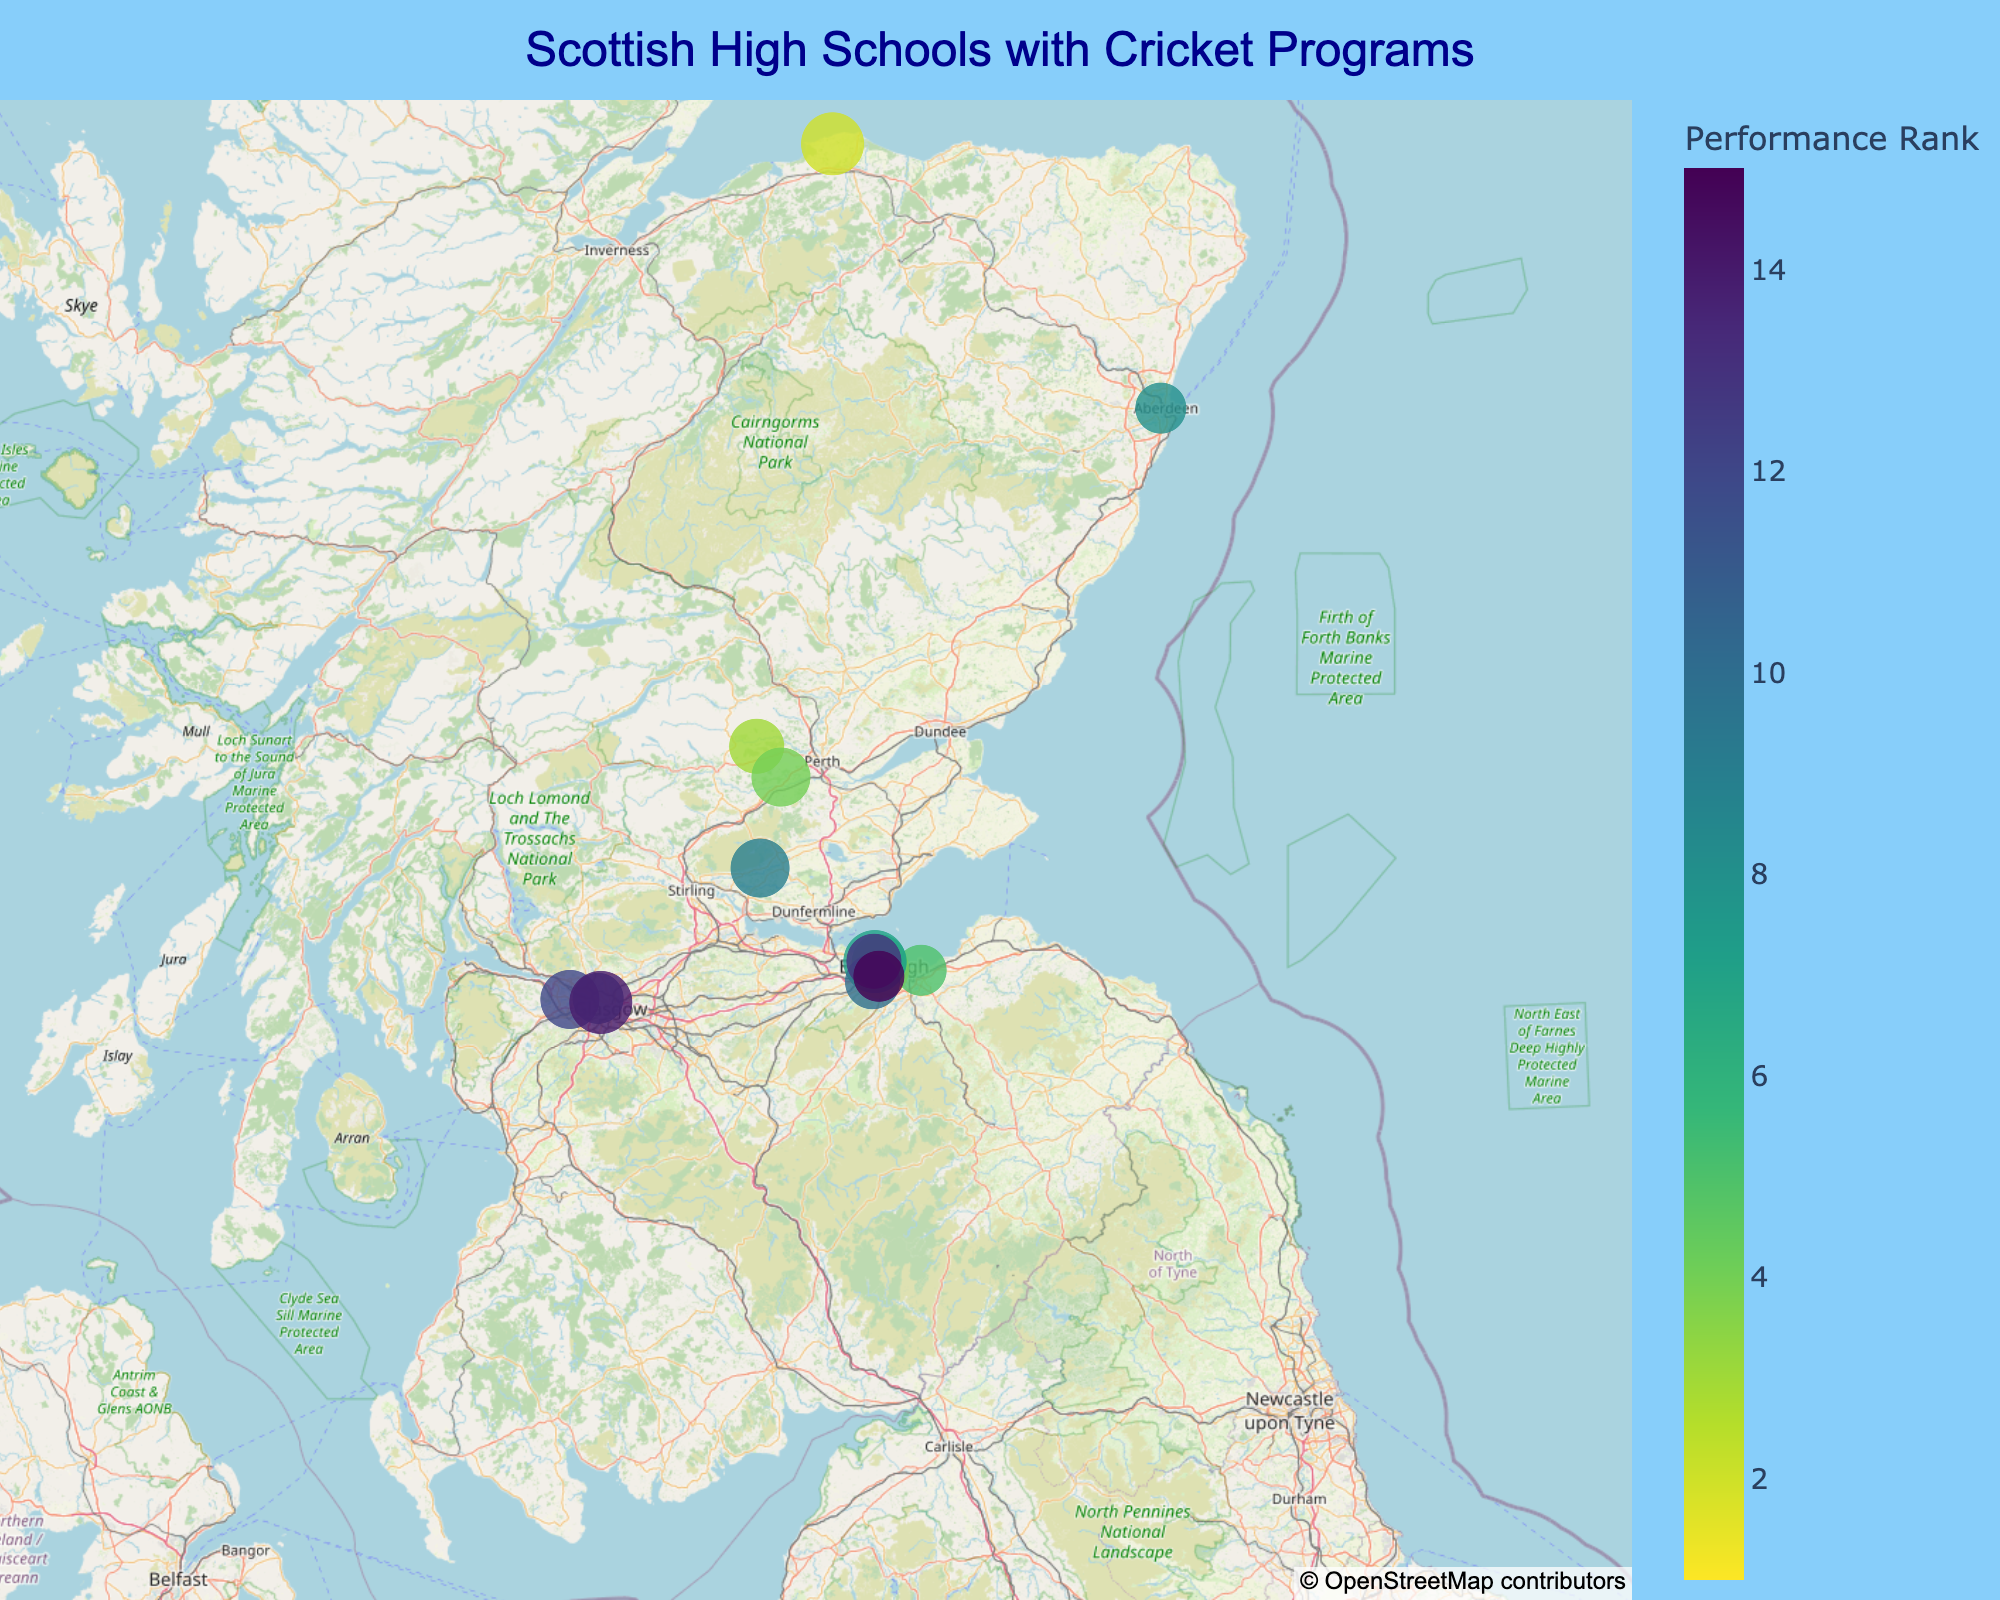What is the title of the geographic plot? The title is displayed at the top of the plot, centered and in a dark blue font. It reads "Scottish High Schools with Cricket Programs".
Answer: Scottish High Schools with Cricket Programs Which school has the highest performance rank and what is its team size? By examining the marker with the smallest numerical value for the Performance Rank, the highest rank is 1. The corresponding school is George Heriot's School, and its team size is shown as 15.
Answer: George Heriot's School, 15 What color is used to indicate the highest performance ranks, and what color represents the lowest? The color scheme used is the Viridis colorscale. The highest performance ranks are represented by colors at the darker end of the spectrum (dark purple), while the lowest ranks are represented by colors at the lighter end (yellow-green).
Answer: Dark purple, yellow-green How many schools have a team size of 14? By inspecting the markers, you see that different markers are sized according to team size. Counting the markers sized for team size 14, there are four schools with this size: Glenalmond College, Edinburgh Academy, Merchiston Castle School, and Stewart's Melville College.
Answer: 4 Which school is located furthest north and what is its performance rank? By examining the latitude values of the markers on the plot, the school located furthest north is Gordonstoun School, which has a latitude of 57.6985. Its performance rank is shown as 2.
Answer: Gordonstoun School, 2 What is the average performance rank of the schools located in Edinburgh? The schools located in Edinburgh are George Heriot's School (1), Loretto School (5), Edinburgh Academy (6), Fettes College (7), Stewart's Melville College (13), and George Watson's College (15). Calculate the average rank by summing these ranks and dividing by the number of schools: (1+5+6+7+13+15) / 6 = 47 / 6 = 7.83.
Answer: 7.83 Which school is closest to the center of the map? The center of the map is calculated as the mean latitude and longitude of all the schools. Mentally estimating or using precise calculation (Edinburgh region is centered, around lat ~55.94, lon ~-3.21), the central point is close to George Heriot's School or George Watson's College. By assumption of nearby markers, George Heriot's School seems closest.
Answer: George Heriot's School Compare the performance ranks of the two schools in Glasgow. Identify the schools by looking at the coordinates in Glasgow (approx lat 55.8723, lon -4.2921). The two schools are Glasgow Academy (rank 11) and High School of Glasgow (rank 14). Clearly, Glasgow Academy has a higher performance rank compared to High School of Glasgow.
Answer: Glasgow Academy, High School of Glasgow Which school has the largest team size, and what is its performance rank? Inspect the plot for the largest markers as they represent the largest team sizes. The largest team size is 16, shared by Gordonstoun School, Fettes College, and High School of Glasgow. Their ranks are 2, 7, and 14 respectively.
Answer: Gordonstoun School, 2; Fettes College, 7; High School of Glasgow, 14 